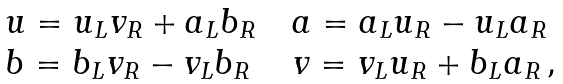Convert formula to latex. <formula><loc_0><loc_0><loc_500><loc_500>\begin{array} { l } { { u = u _ { L } v _ { R } + a _ { L } b _ { R } \quad a = a _ { L } u _ { R } - u _ { L } a _ { R } } } \\ { { b = b _ { L } v _ { R } - v _ { L } b _ { R } \, \quad v = v _ { L } u _ { R } + b _ { L } a _ { R } \, , } } \end{array}</formula> 